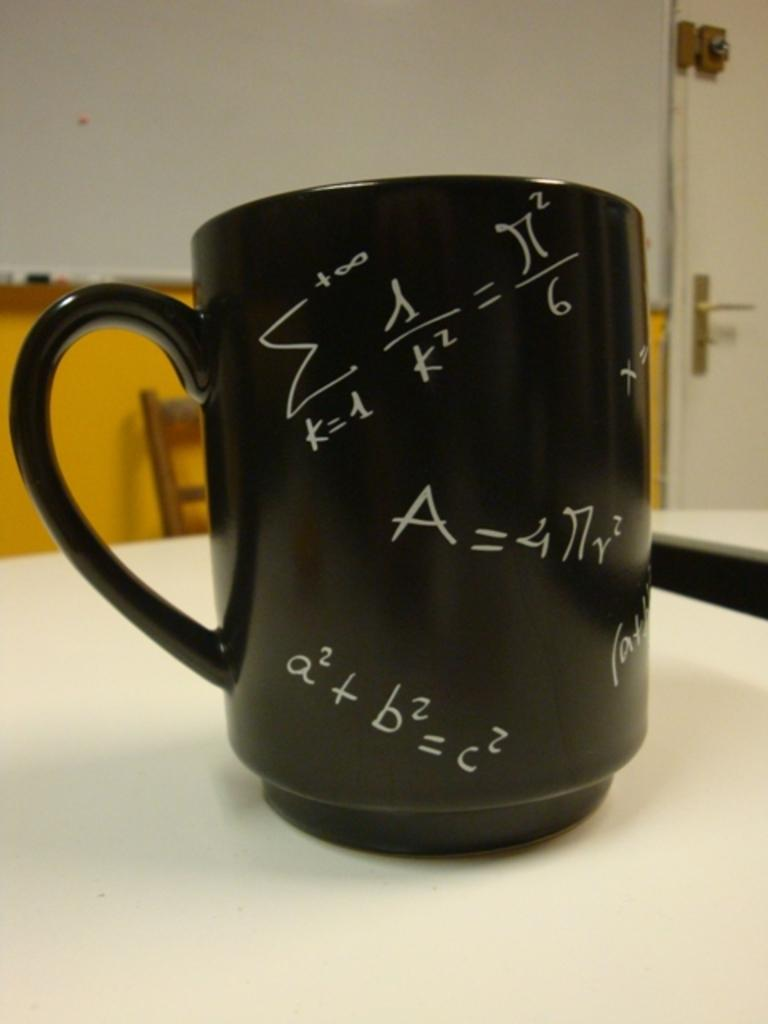Provide a one-sentence caption for the provided image. A coffee mug with a2 +b2=c2 and a few other math problems all over it. 